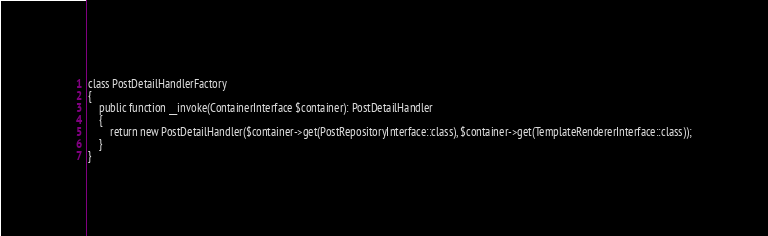<code> <loc_0><loc_0><loc_500><loc_500><_PHP_>
class PostDetailHandlerFactory
{
    public function __invoke(ContainerInterface $container): PostDetailHandler
    {
        return new PostDetailHandler($container->get(PostRepositoryInterface::class), $container->get(TemplateRendererInterface::class));
    }
}
</code> 